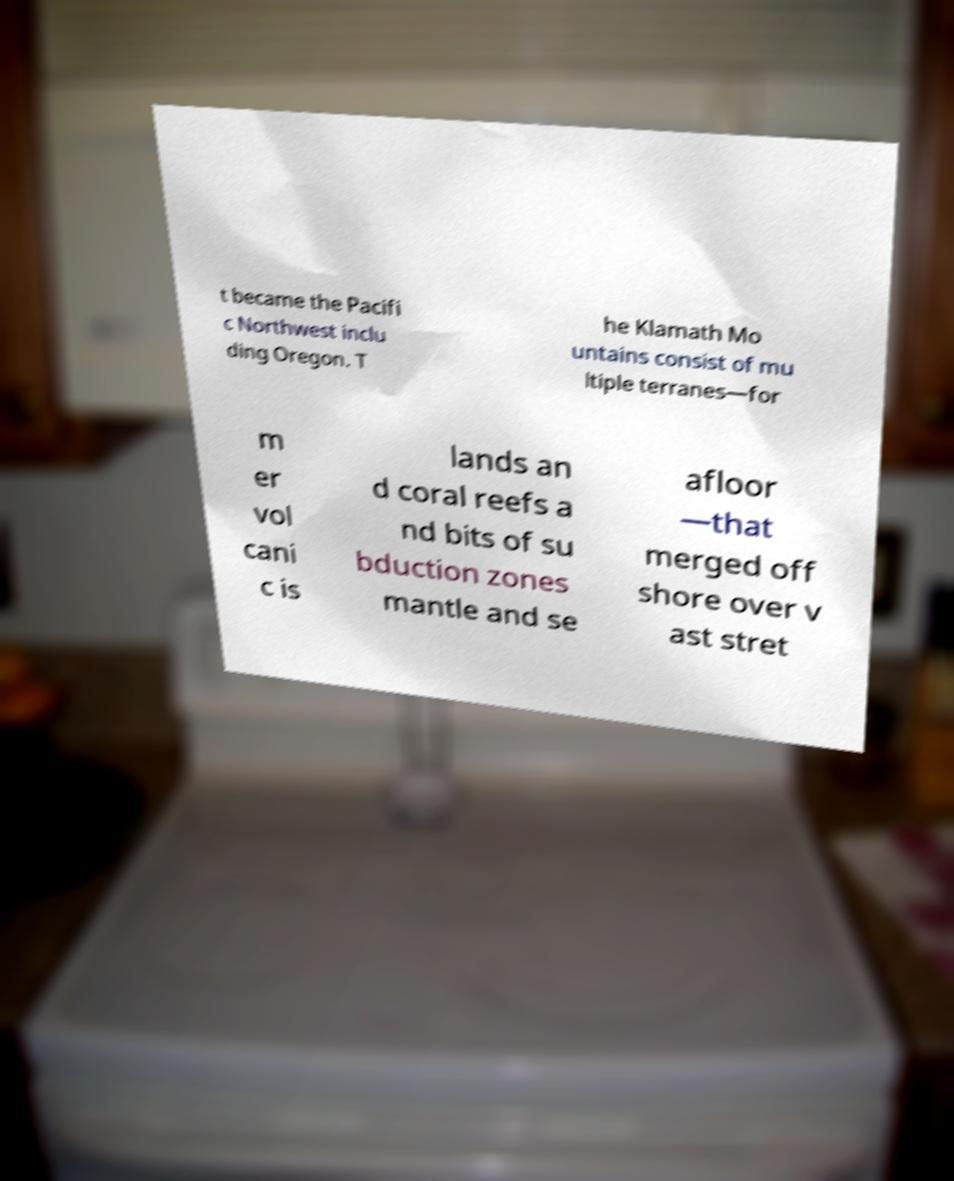There's text embedded in this image that I need extracted. Can you transcribe it verbatim? t became the Pacifi c Northwest inclu ding Oregon. T he Klamath Mo untains consist of mu ltiple terranes—for m er vol cani c is lands an d coral reefs a nd bits of su bduction zones mantle and se afloor —that merged off shore over v ast stret 